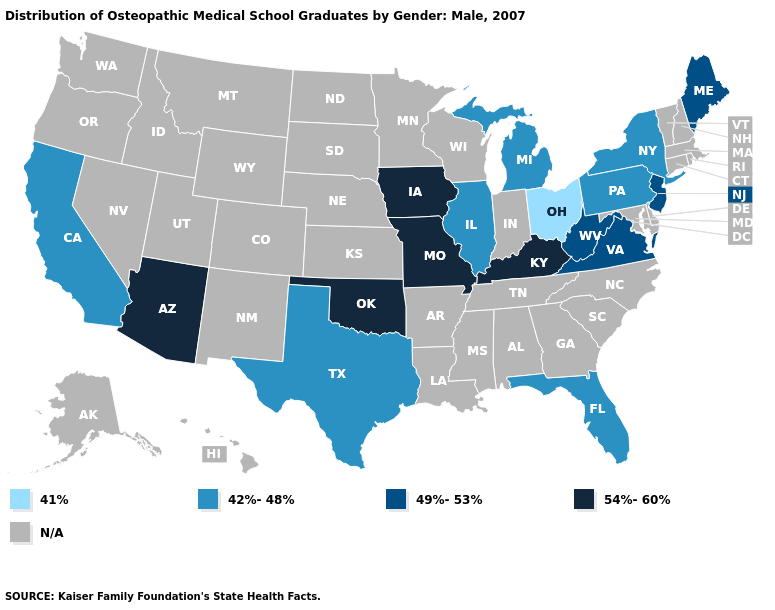Name the states that have a value in the range 42%-48%?
Give a very brief answer. California, Florida, Illinois, Michigan, New York, Pennsylvania, Texas. Does Ohio have the lowest value in the USA?
Quick response, please. Yes. Which states have the highest value in the USA?
Concise answer only. Arizona, Iowa, Kentucky, Missouri, Oklahoma. Which states have the lowest value in the West?
Keep it brief. California. Is the legend a continuous bar?
Write a very short answer. No. What is the highest value in the South ?
Keep it brief. 54%-60%. Does the map have missing data?
Give a very brief answer. Yes. Name the states that have a value in the range N/A?
Short answer required. Alabama, Alaska, Arkansas, Colorado, Connecticut, Delaware, Georgia, Hawaii, Idaho, Indiana, Kansas, Louisiana, Maryland, Massachusetts, Minnesota, Mississippi, Montana, Nebraska, Nevada, New Hampshire, New Mexico, North Carolina, North Dakota, Oregon, Rhode Island, South Carolina, South Dakota, Tennessee, Utah, Vermont, Washington, Wisconsin, Wyoming. Which states have the lowest value in the MidWest?
Write a very short answer. Ohio. Does Florida have the lowest value in the USA?
Quick response, please. No. Name the states that have a value in the range 54%-60%?
Quick response, please. Arizona, Iowa, Kentucky, Missouri, Oklahoma. What is the lowest value in the South?
Write a very short answer. 42%-48%. Does the map have missing data?
Give a very brief answer. Yes. What is the value of Kentucky?
Quick response, please. 54%-60%. 